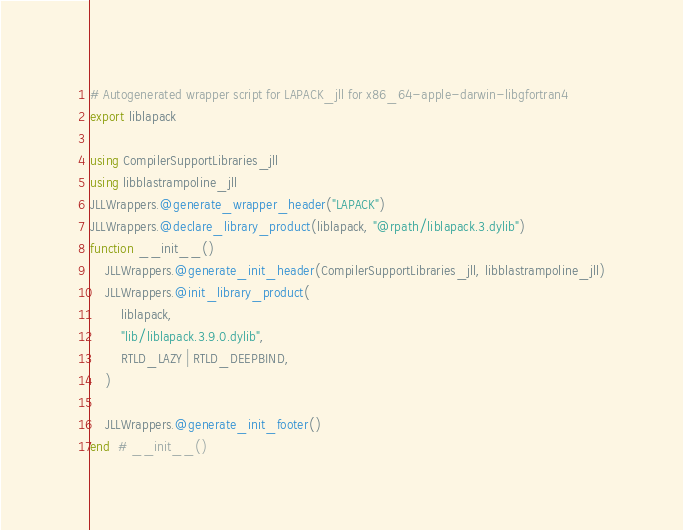Convert code to text. <code><loc_0><loc_0><loc_500><loc_500><_Julia_># Autogenerated wrapper script for LAPACK_jll for x86_64-apple-darwin-libgfortran4
export liblapack

using CompilerSupportLibraries_jll
using libblastrampoline_jll
JLLWrappers.@generate_wrapper_header("LAPACK")
JLLWrappers.@declare_library_product(liblapack, "@rpath/liblapack.3.dylib")
function __init__()
    JLLWrappers.@generate_init_header(CompilerSupportLibraries_jll, libblastrampoline_jll)
    JLLWrappers.@init_library_product(
        liblapack,
        "lib/liblapack.3.9.0.dylib",
        RTLD_LAZY | RTLD_DEEPBIND,
    )

    JLLWrappers.@generate_init_footer()
end  # __init__()
</code> 